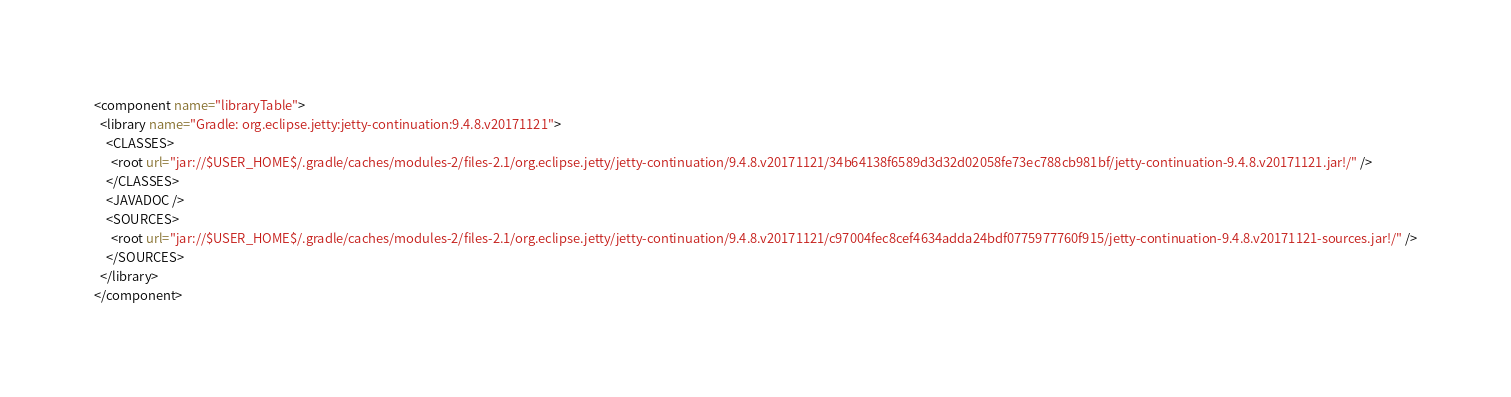<code> <loc_0><loc_0><loc_500><loc_500><_XML_><component name="libraryTable">
  <library name="Gradle: org.eclipse.jetty:jetty-continuation:9.4.8.v20171121">
    <CLASSES>
      <root url="jar://$USER_HOME$/.gradle/caches/modules-2/files-2.1/org.eclipse.jetty/jetty-continuation/9.4.8.v20171121/34b64138f6589d3d32d02058fe73ec788cb981bf/jetty-continuation-9.4.8.v20171121.jar!/" />
    </CLASSES>
    <JAVADOC />
    <SOURCES>
      <root url="jar://$USER_HOME$/.gradle/caches/modules-2/files-2.1/org.eclipse.jetty/jetty-continuation/9.4.8.v20171121/c97004fec8cef4634adda24bdf0775977760f915/jetty-continuation-9.4.8.v20171121-sources.jar!/" />
    </SOURCES>
  </library>
</component></code> 